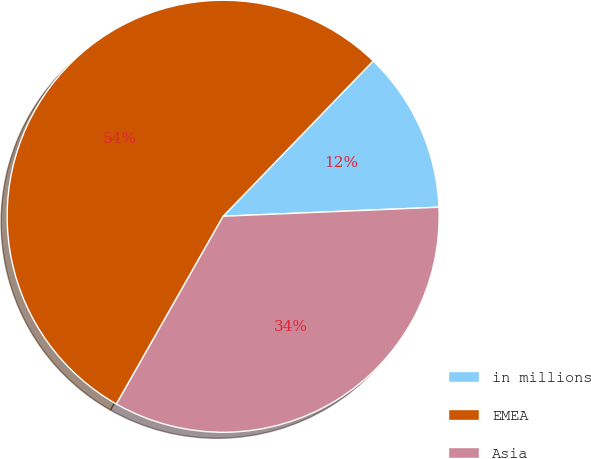Convert chart to OTSL. <chart><loc_0><loc_0><loc_500><loc_500><pie_chart><fcel>in millions<fcel>EMEA<fcel>Asia<nl><fcel>12.11%<fcel>54.0%<fcel>33.89%<nl></chart> 